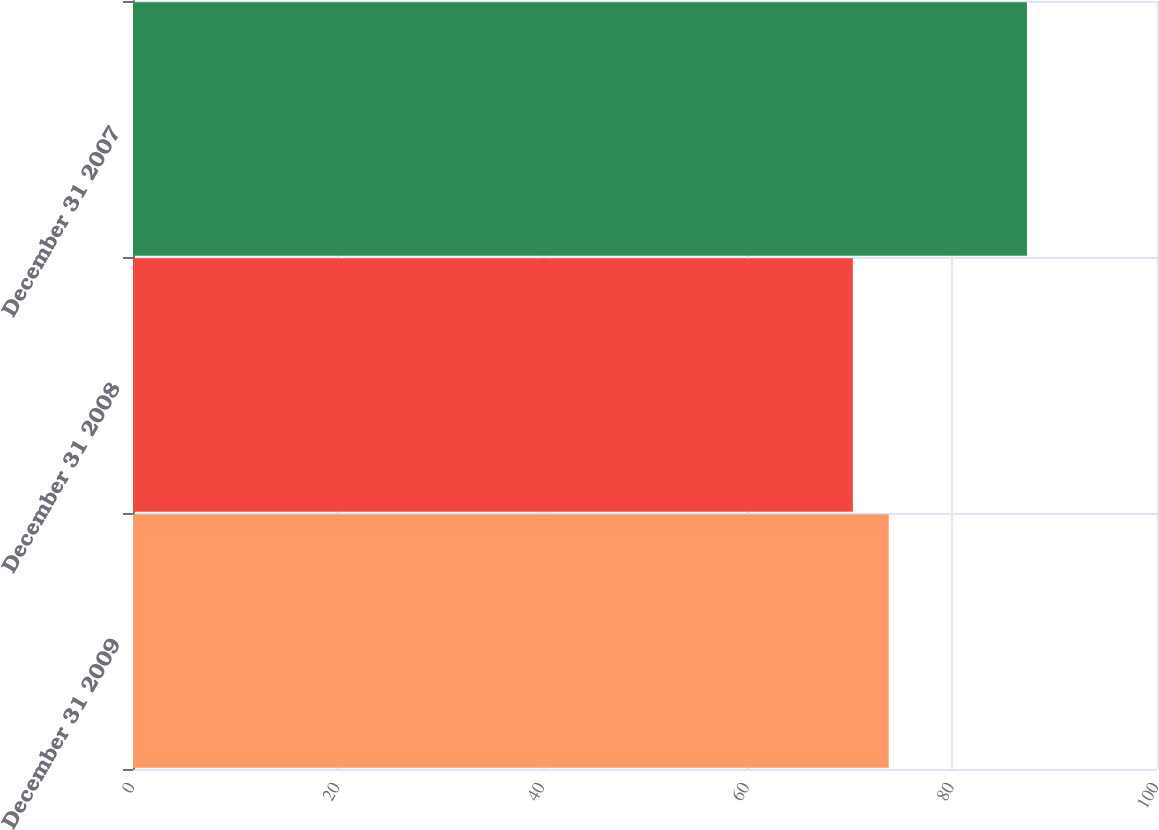Convert chart to OTSL. <chart><loc_0><loc_0><loc_500><loc_500><bar_chart><fcel>December 31 2009<fcel>December 31 2008<fcel>December 31 2007<nl><fcel>73.8<fcel>70.3<fcel>87.3<nl></chart> 